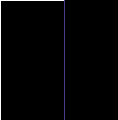<code> <loc_0><loc_0><loc_500><loc_500><_Dockerfile_>

</code> 